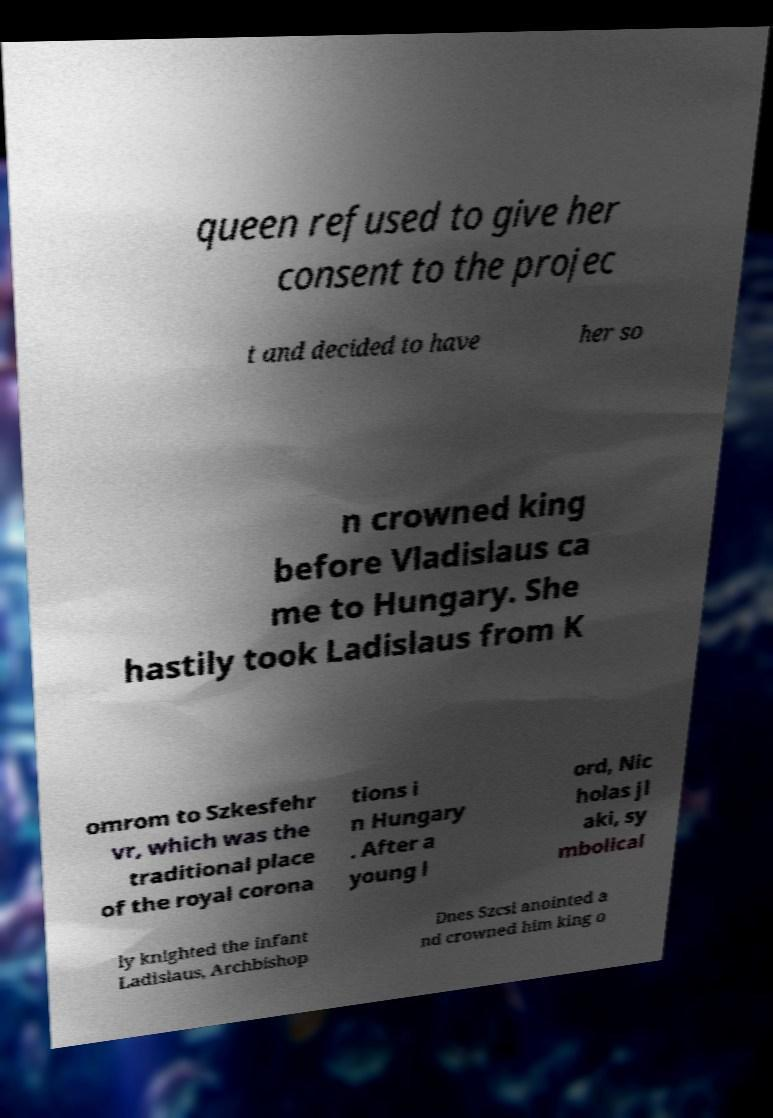For documentation purposes, I need the text within this image transcribed. Could you provide that? queen refused to give her consent to the projec t and decided to have her so n crowned king before Vladislaus ca me to Hungary. She hastily took Ladislaus from K omrom to Szkesfehr vr, which was the traditional place of the royal corona tions i n Hungary . After a young l ord, Nic holas jl aki, sy mbolical ly knighted the infant Ladislaus, Archbishop Dnes Szcsi anointed a nd crowned him king o 